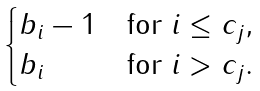Convert formula to latex. <formula><loc_0><loc_0><loc_500><loc_500>\begin{cases} b _ { i } - 1 & \text {for $i \leq c_{j}$} , \\ b _ { i } & \text {for $i> c_{j}$} . \end{cases}</formula> 